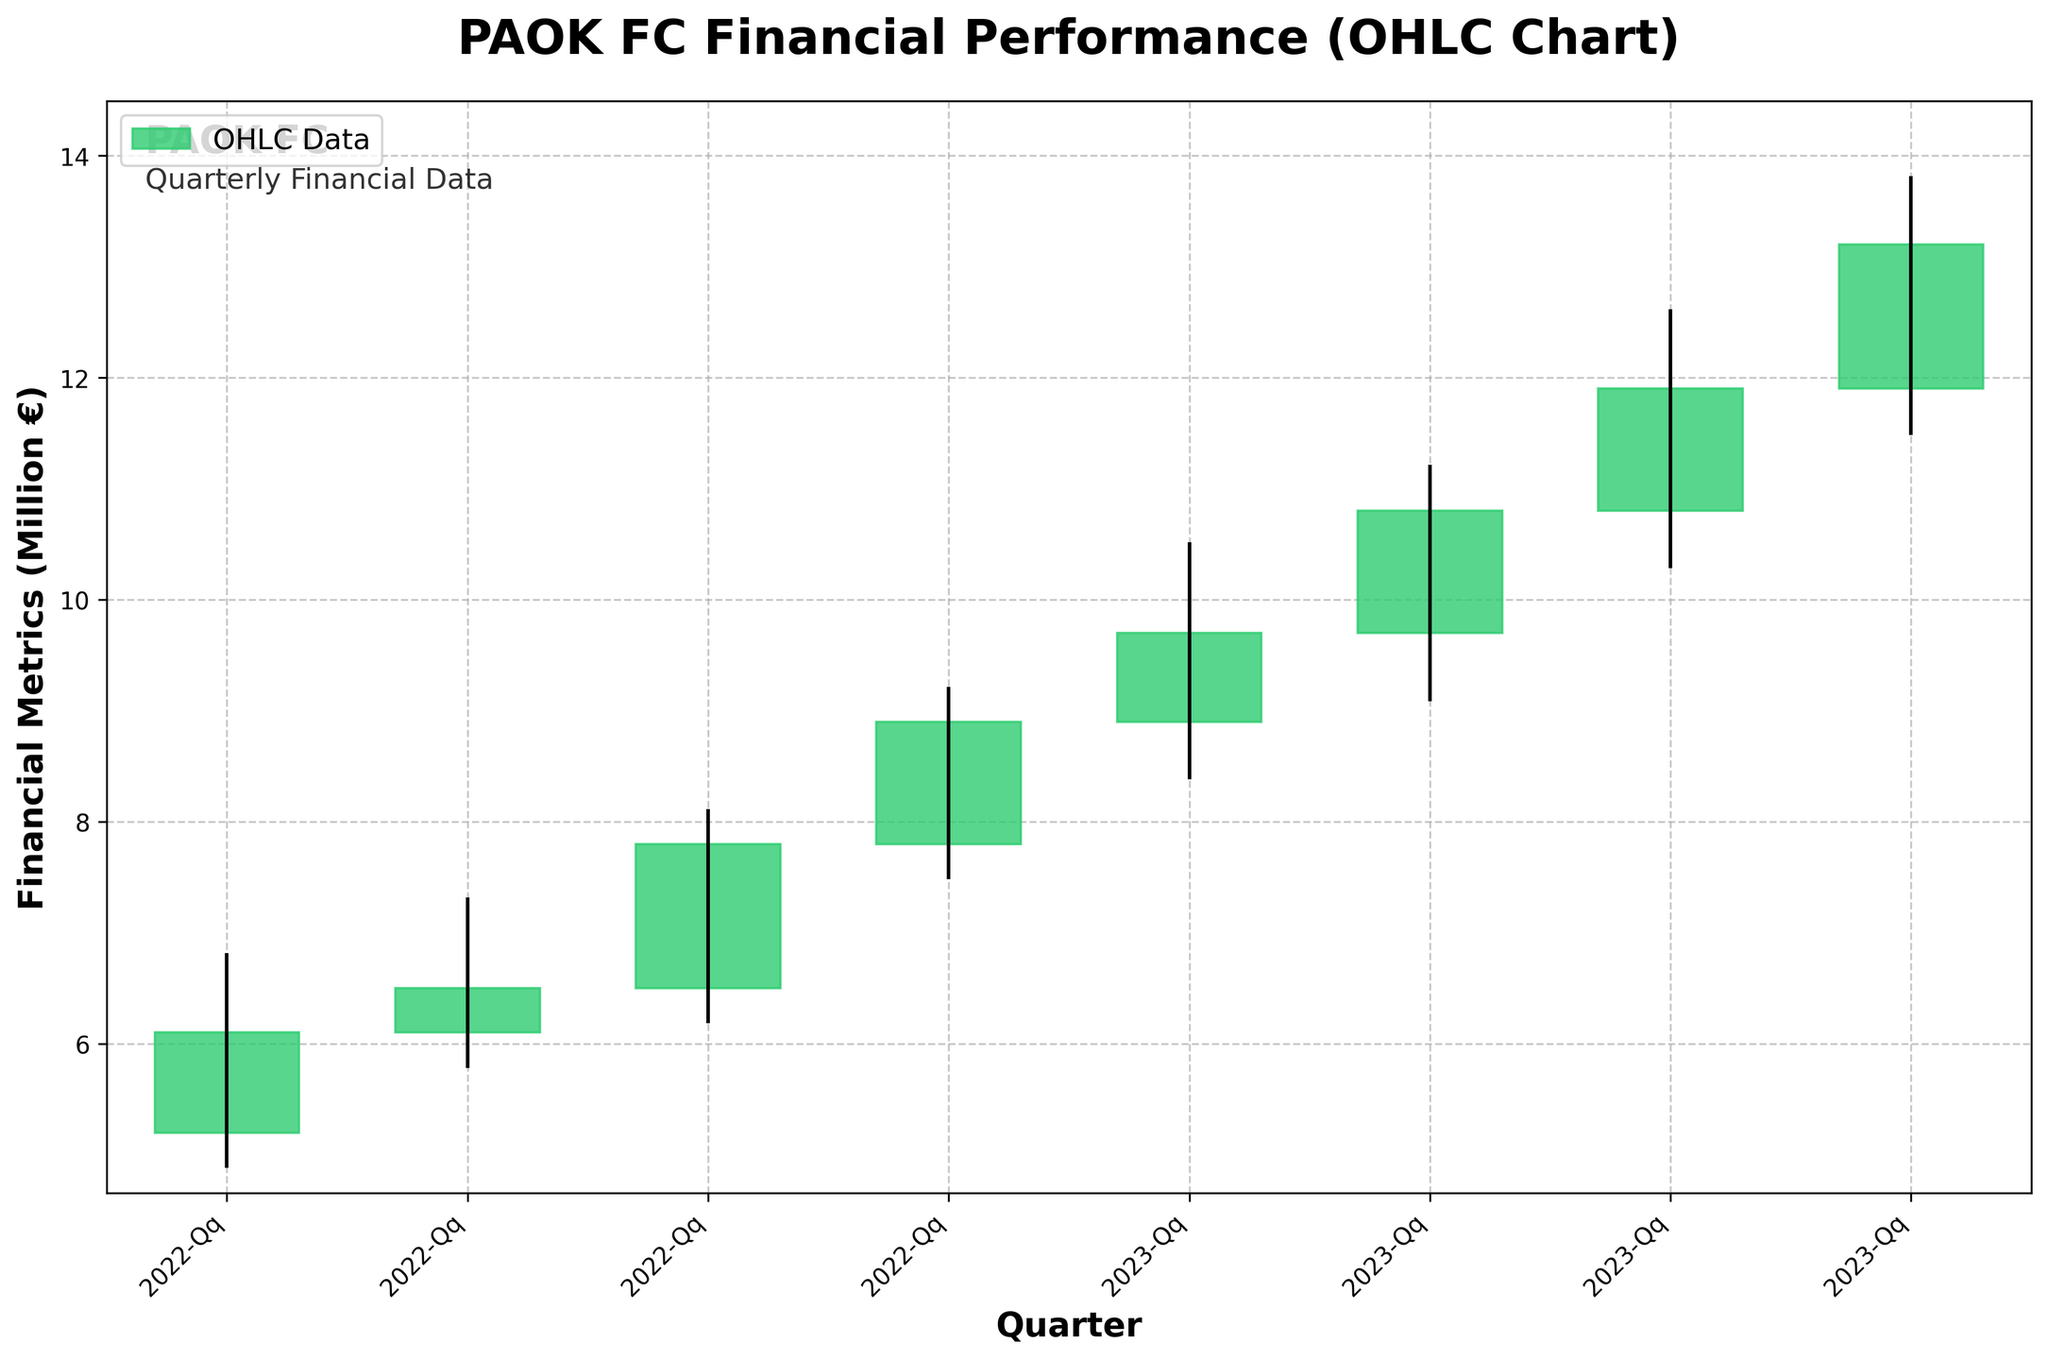What is the title of the OHLC chart? The title of the chart is usually found at the top of the figure and provides an overview of what the data represents.
Answer: PAOK FC Financial Performance (OHLC Chart) How many quarters are displayed in the chart? To find the number of quarters, look at the x-axis labels which indicate each quarter. Count the number of unique labels.
Answer: 8 Which quarter had the highest high value and what was it? Check the peaks of the wicks of each candle and note the highest value. This corresponds to the maximum high value.
Answer: 2023-Q4, 13.8 What is the overall trend from 2022-Q1 to 2023-Q4, increasing or decreasing? Compare the starting point (2022-Q1) to the ending point (2023-Q4) of the closing values to identify the overall trend.
Answer: Increasing Which quarters had a closing value higher than its opening value? Look for candles where the close value is higher than the open value, usually represented by a green candle.
Answer: 2022-Q1, 2022-Q2, 2022-Q3, 2022-Q4, 2023-Q1, 2023-Q2, 2023-Q3, 2023-Q4 What is the average of the high values for 2023? Sum the high values for all the quarters in 2023 and then divide by the number of quarters. (10.5, 11.2, 12.6, and 13.8 add up to 48.1 and then divide by 4)
Answer: 12.025 Which quarter had the smallest range between its high and low values? For each quarter, subtract the low value from the high value, then find the quarter with the smallest difference.
Answer: 2022-Q2 Between 2022-Q3 and 2023-Q3, which quarter showed the highest closing value? Compare the closing values of the specified quarters and identify the highest one. Read the close prices from 2022-Q3 (7.8) and 2023-Q3 (11.9).
Answer: 2023-Q3 Which quarter had the lowest low value? Check the bottom of the wicks for each candle and note the lowest value. This corresponds to the minimum low value.
Answer: 2022-Q1, 4.9 